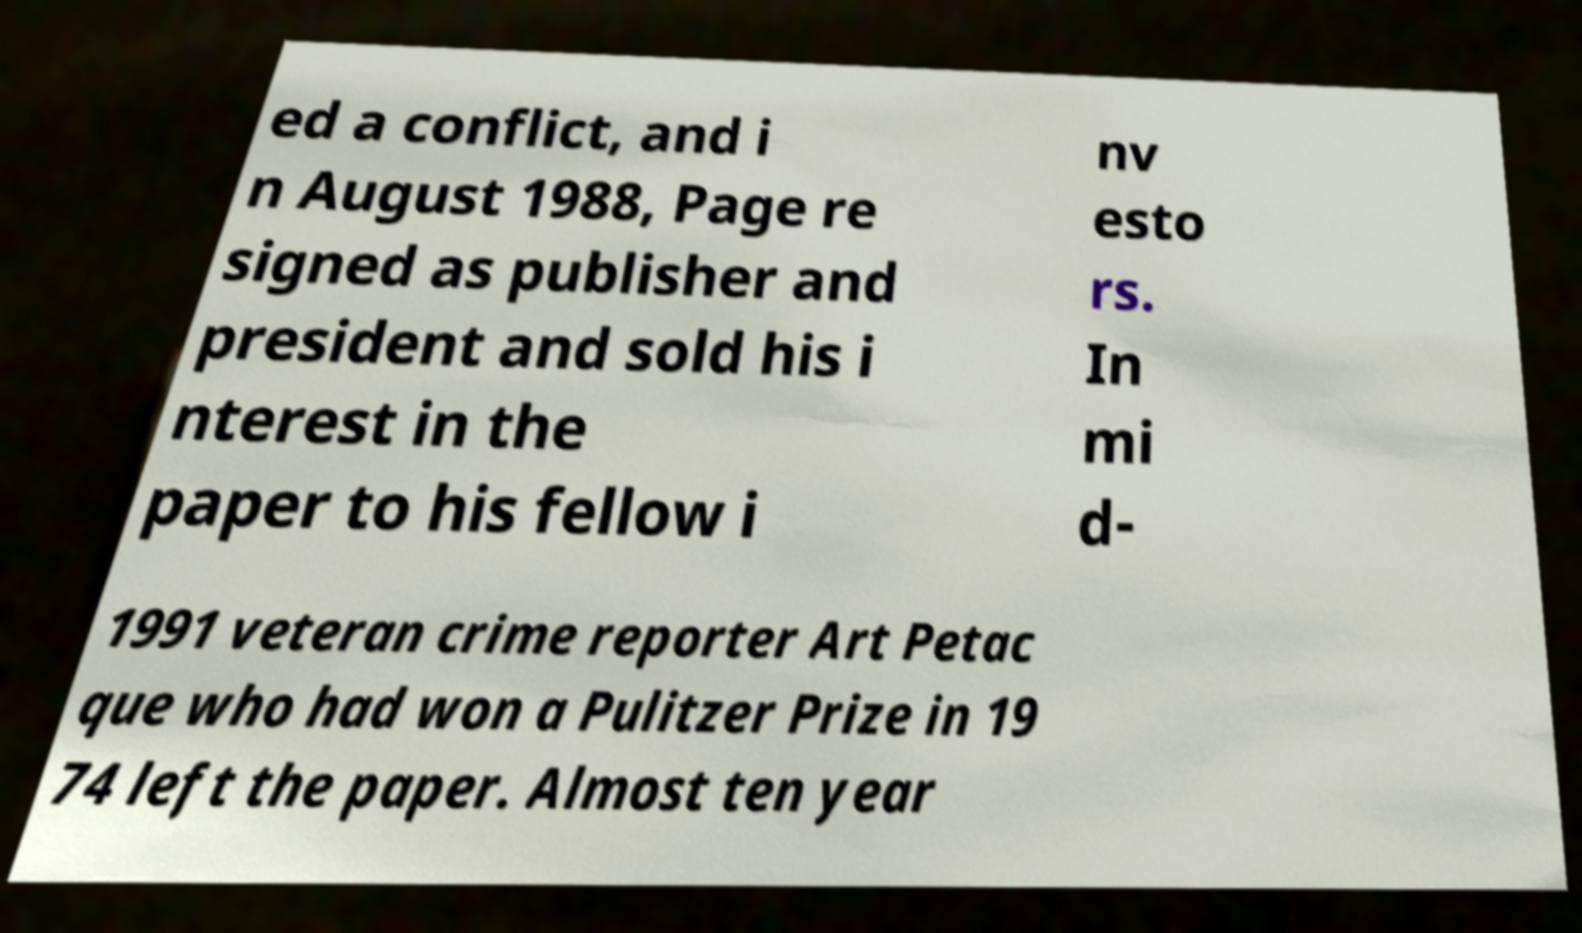There's text embedded in this image that I need extracted. Can you transcribe it verbatim? ed a conflict, and i n August 1988, Page re signed as publisher and president and sold his i nterest in the paper to his fellow i nv esto rs. In mi d- 1991 veteran crime reporter Art Petac que who had won a Pulitzer Prize in 19 74 left the paper. Almost ten year 